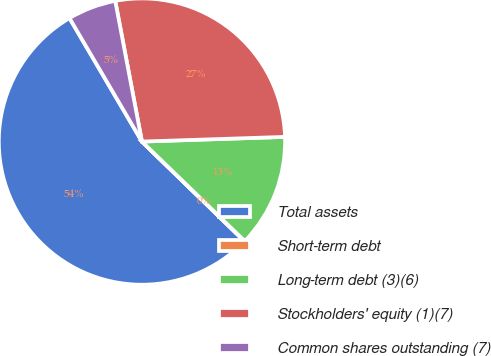Convert chart to OTSL. <chart><loc_0><loc_0><loc_500><loc_500><pie_chart><fcel>Total assets<fcel>Short-term debt<fcel>Long-term debt (3)(6)<fcel>Stockholders' equity (1)(7)<fcel>Common shares outstanding (7)<nl><fcel>54.28%<fcel>0.04%<fcel>12.76%<fcel>27.47%<fcel>5.46%<nl></chart> 